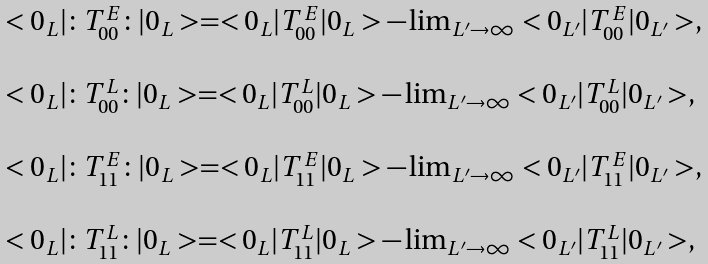<formula> <loc_0><loc_0><loc_500><loc_500>\begin{array} { l l } < 0 _ { L } | \colon T _ { 0 0 } ^ { E } \colon | 0 _ { L } > = < 0 _ { L } | T _ { 0 0 } ^ { E } | 0 _ { L } > - \lim _ { L ^ { \prime } \rightarrow \infty } < 0 _ { L ^ { \prime } } | T _ { 0 0 } ^ { E } | 0 _ { L ^ { \prime } } > , \\ \\ < 0 _ { L } | \colon T _ { 0 0 } ^ { L } \colon | 0 _ { L } > = < 0 _ { L } | T _ { 0 0 } ^ { L } | 0 _ { L } > - \lim _ { L ^ { \prime } \rightarrow \infty } < 0 _ { L ^ { \prime } } | T _ { 0 0 } ^ { L } | 0 _ { L ^ { \prime } } > , \\ \\ < 0 _ { L } | \colon T _ { 1 1 } ^ { E } \colon | 0 _ { L } > = < 0 _ { L } | T _ { 1 1 } ^ { E } | 0 _ { L } > - \lim _ { L ^ { \prime } \rightarrow \infty } < 0 _ { L ^ { \prime } } | T _ { 1 1 } ^ { E } | 0 _ { L ^ { \prime } } > , \\ \\ < 0 _ { L } | \colon T _ { 1 1 } ^ { L } \colon | 0 _ { L } > = < 0 _ { L } | T _ { 1 1 } ^ { L } | 0 _ { L } > - \lim _ { L ^ { \prime } \rightarrow \infty } < 0 _ { L ^ { \prime } } | T _ { 1 1 } ^ { L } | 0 _ { L ^ { \prime } } > , \end{array}</formula> 